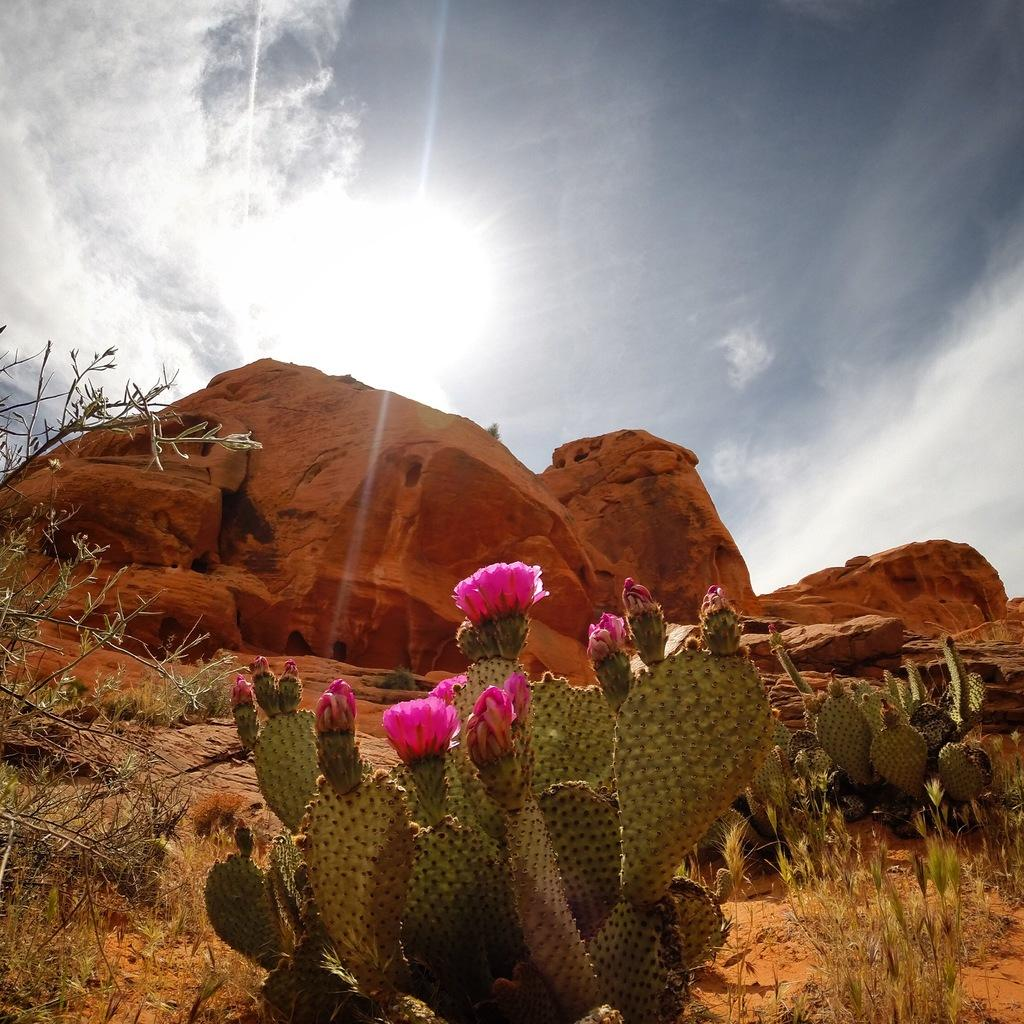What type of living organisms can be seen in the image? There are flowers and plants visible in the image. What other objects can be seen in the image? There are rocks in the image. What is visible in the sky in the image? The sun is visible in the sky. How much money is being exchanged between the bears in the image? There are no bears present in the image, and therefore no money exchange can be observed. 